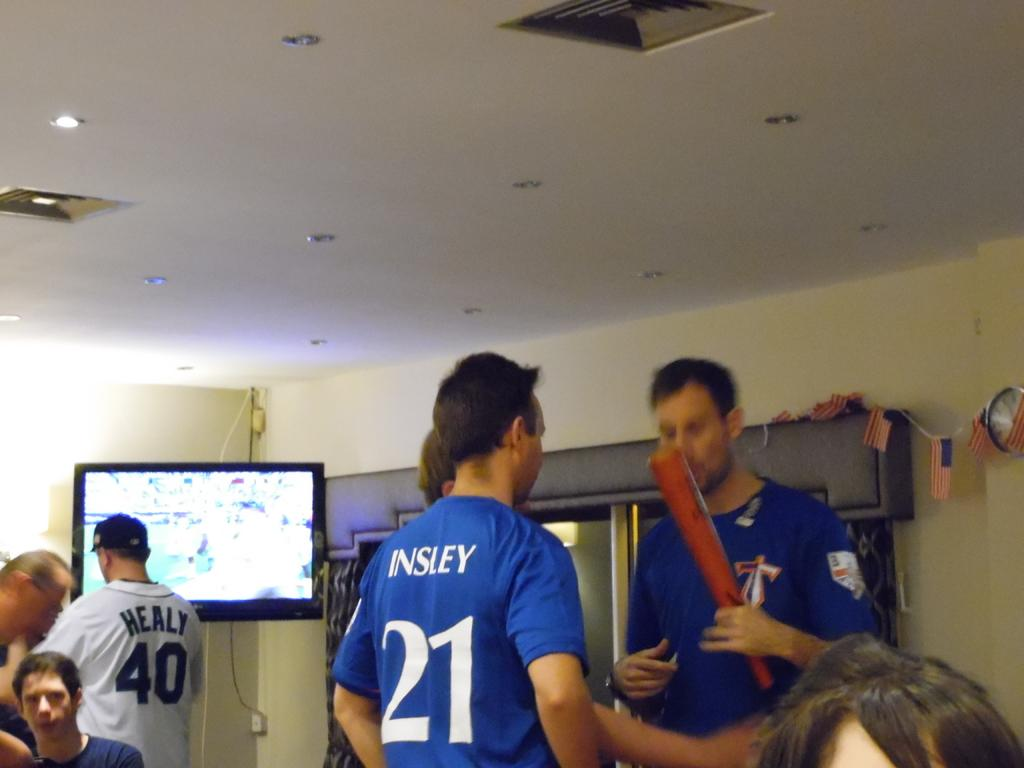<image>
Present a compact description of the photo's key features. Two popular players are Healy and Insley since people are wearing their jersey's. 